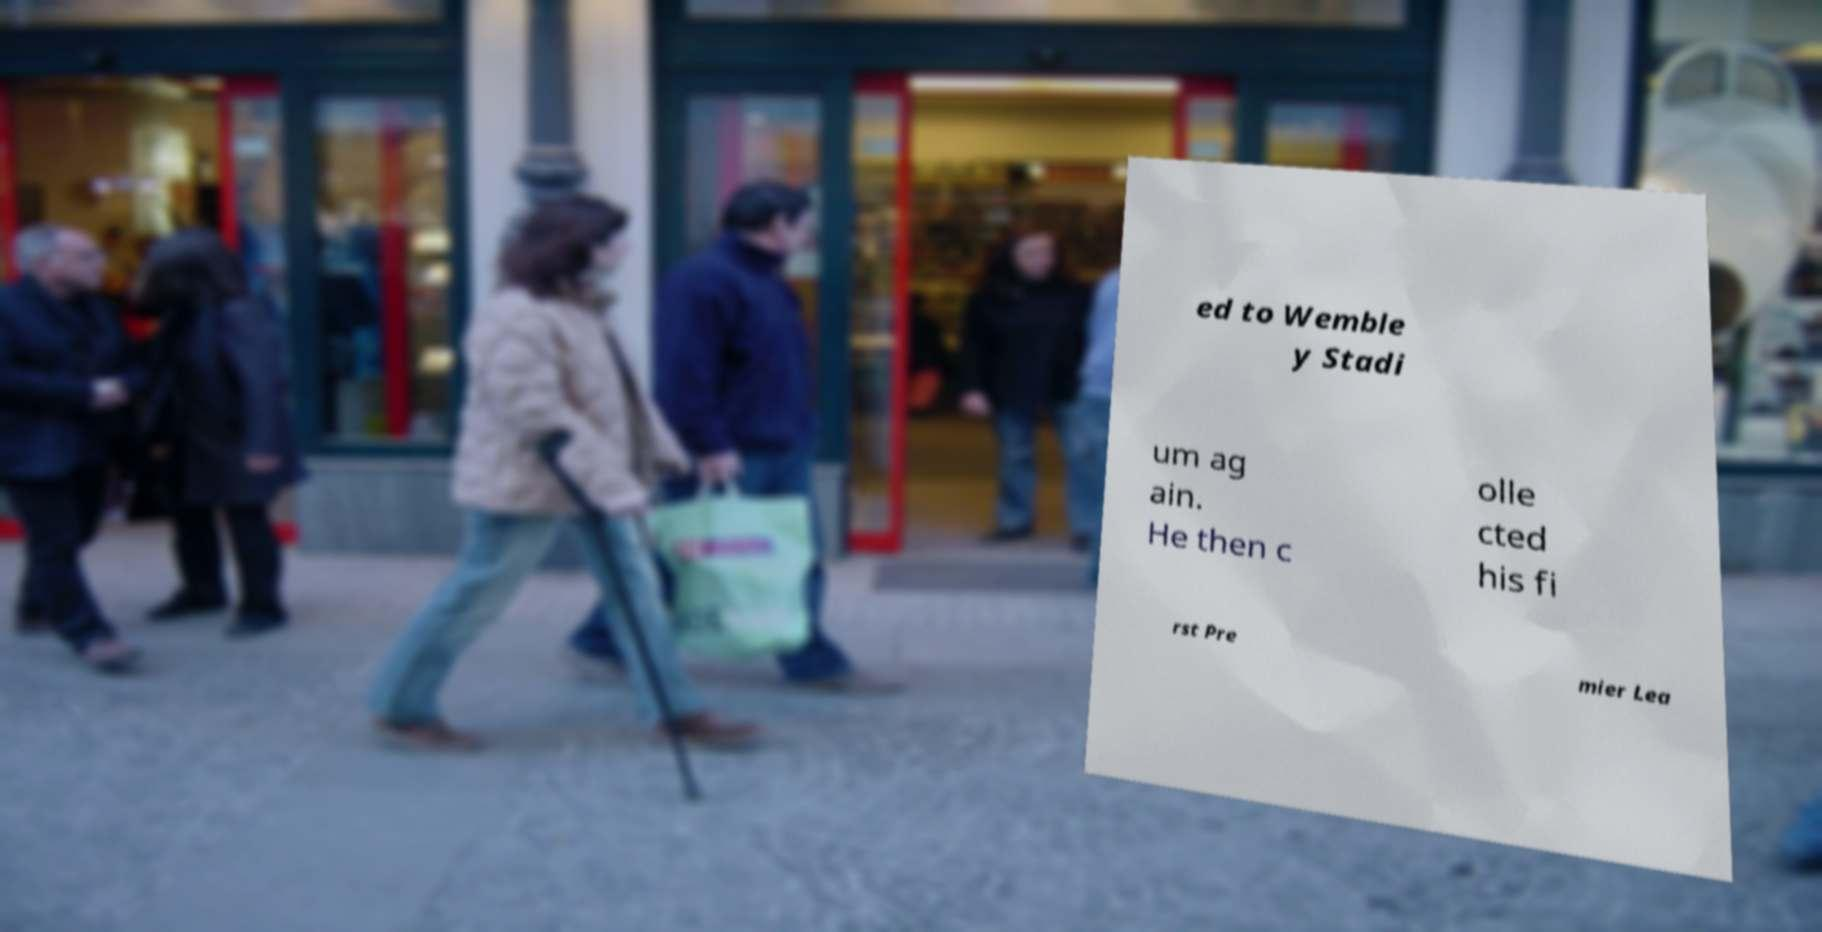Please read and relay the text visible in this image. What does it say? ed to Wemble y Stadi um ag ain. He then c olle cted his fi rst Pre mier Lea 